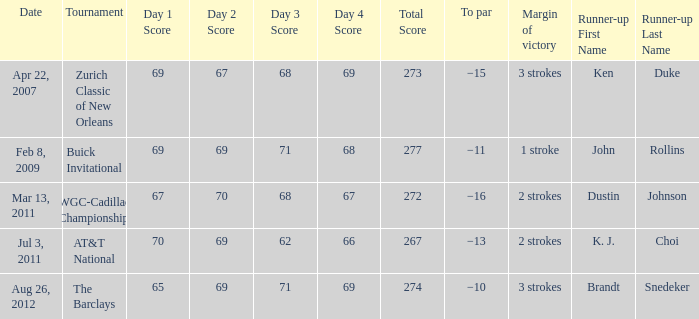On which date did someone achieve a winning score of 67-70-68-67, totaling 272? Mar 13, 2011. 